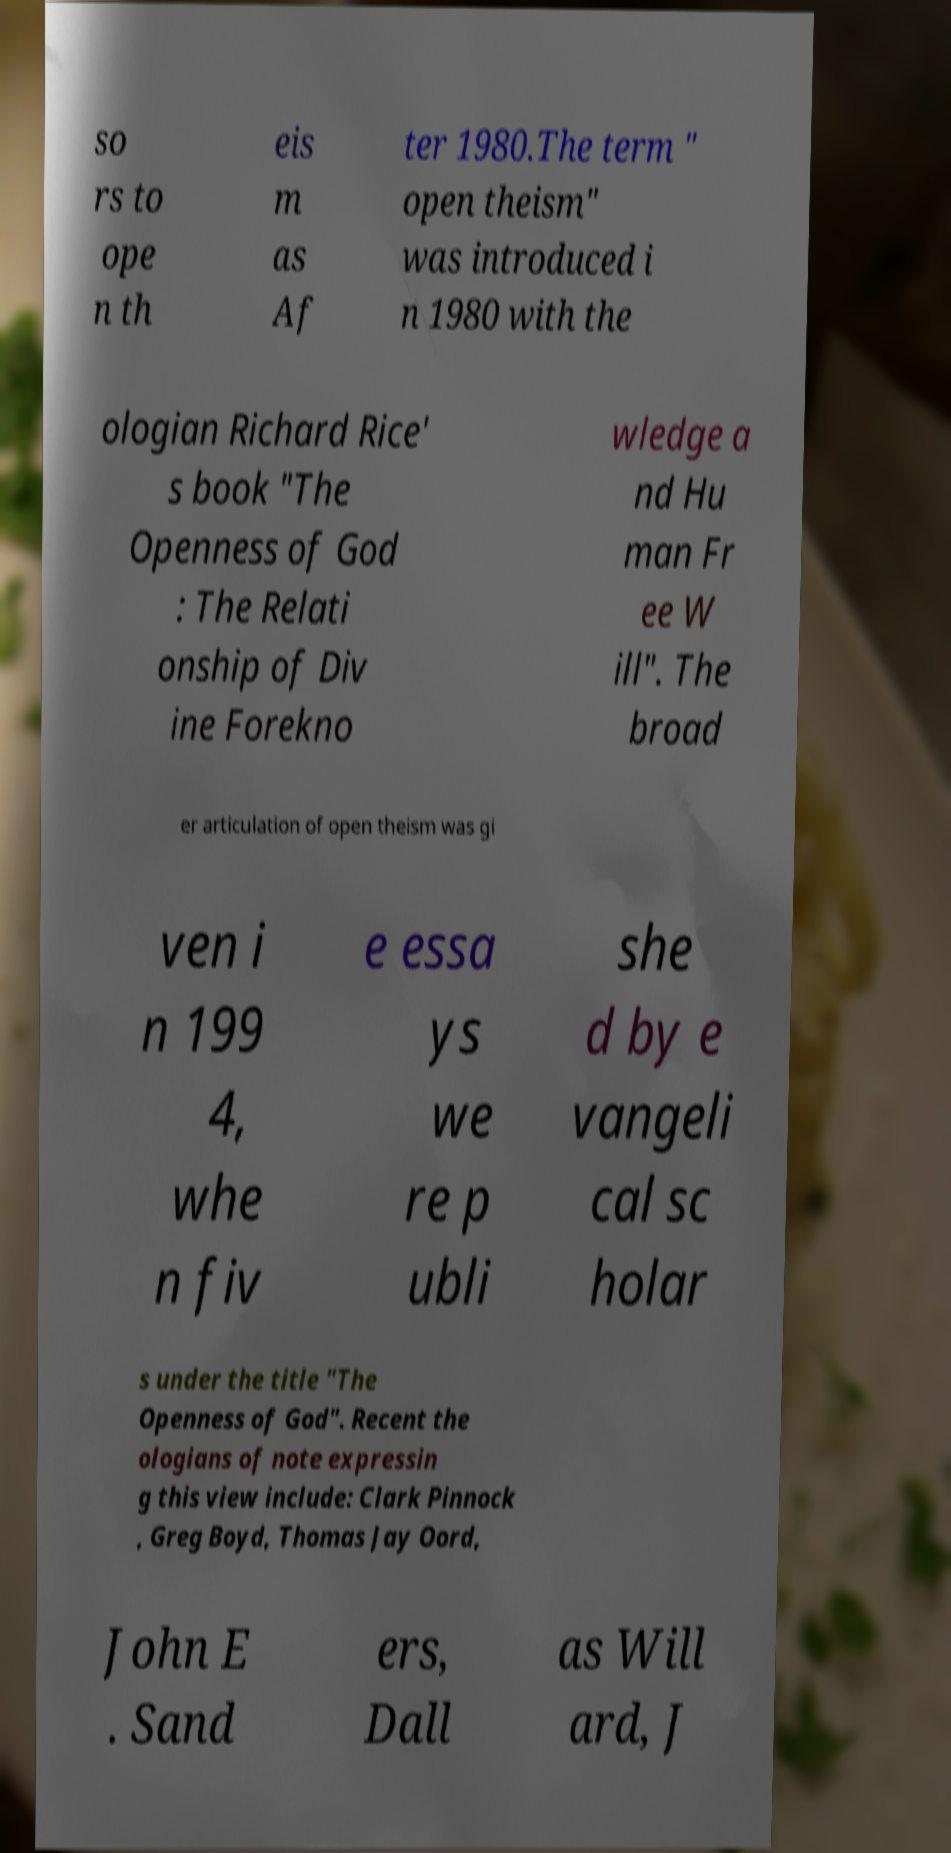Could you extract and type out the text from this image? so rs to ope n th eis m as Af ter 1980.The term " open theism" was introduced i n 1980 with the ologian Richard Rice' s book "The Openness of God : The Relati onship of Div ine Forekno wledge a nd Hu man Fr ee W ill". The broad er articulation of open theism was gi ven i n 199 4, whe n fiv e essa ys we re p ubli she d by e vangeli cal sc holar s under the title "The Openness of God". Recent the ologians of note expressin g this view include: Clark Pinnock , Greg Boyd, Thomas Jay Oord, John E . Sand ers, Dall as Will ard, J 